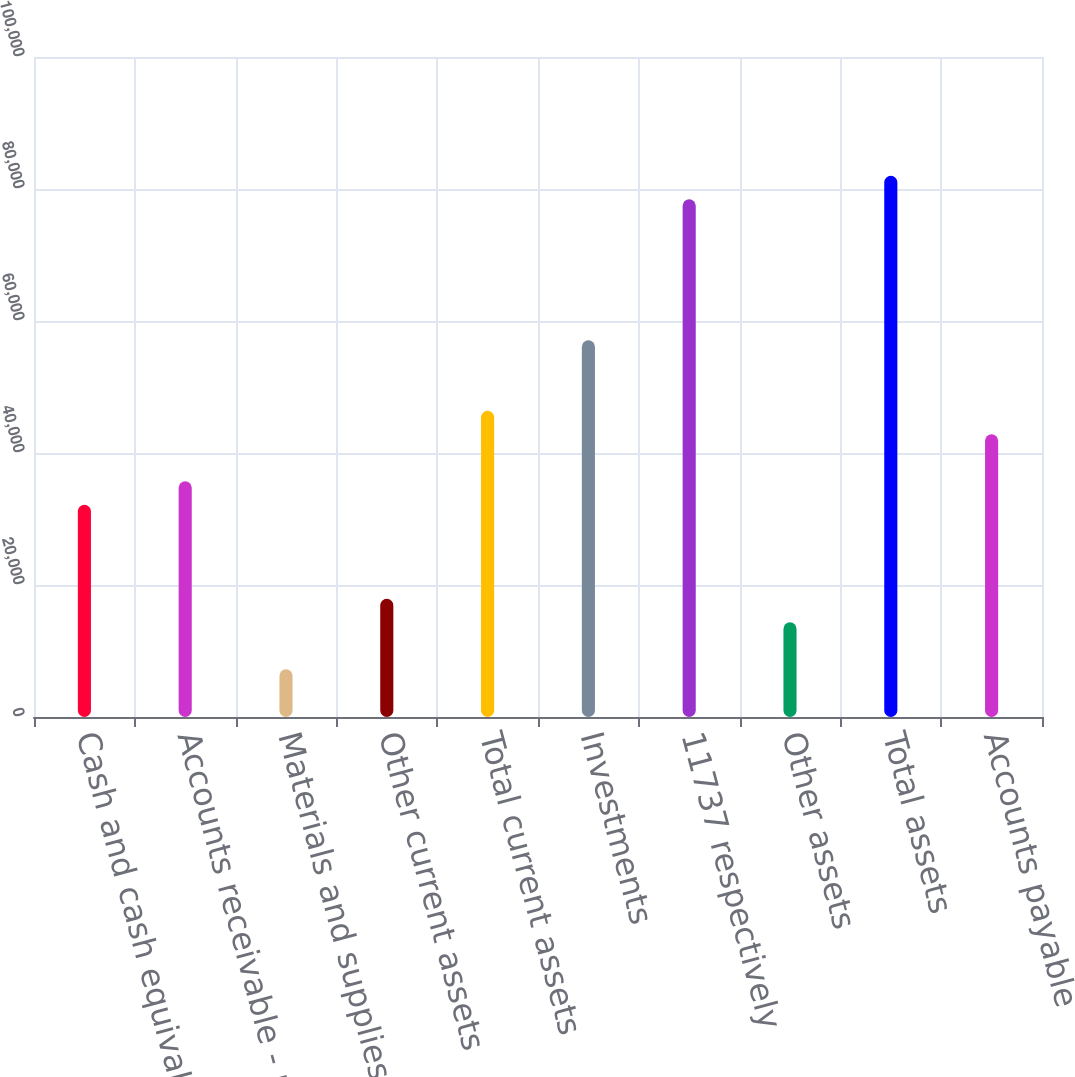Convert chart. <chart><loc_0><loc_0><loc_500><loc_500><bar_chart><fcel>Cash and cash equivalents<fcel>Accounts receivable - net<fcel>Materials and supplies<fcel>Other current assets<fcel>Total current assets<fcel>Investments<fcel>11737 respectively<fcel>Other assets<fcel>Total assets<fcel>Accounts payable<nl><fcel>32149.9<fcel>35711<fcel>7222.2<fcel>17905.5<fcel>46394.3<fcel>57077.6<fcel>78444.2<fcel>14344.4<fcel>82005.3<fcel>42833.2<nl></chart> 